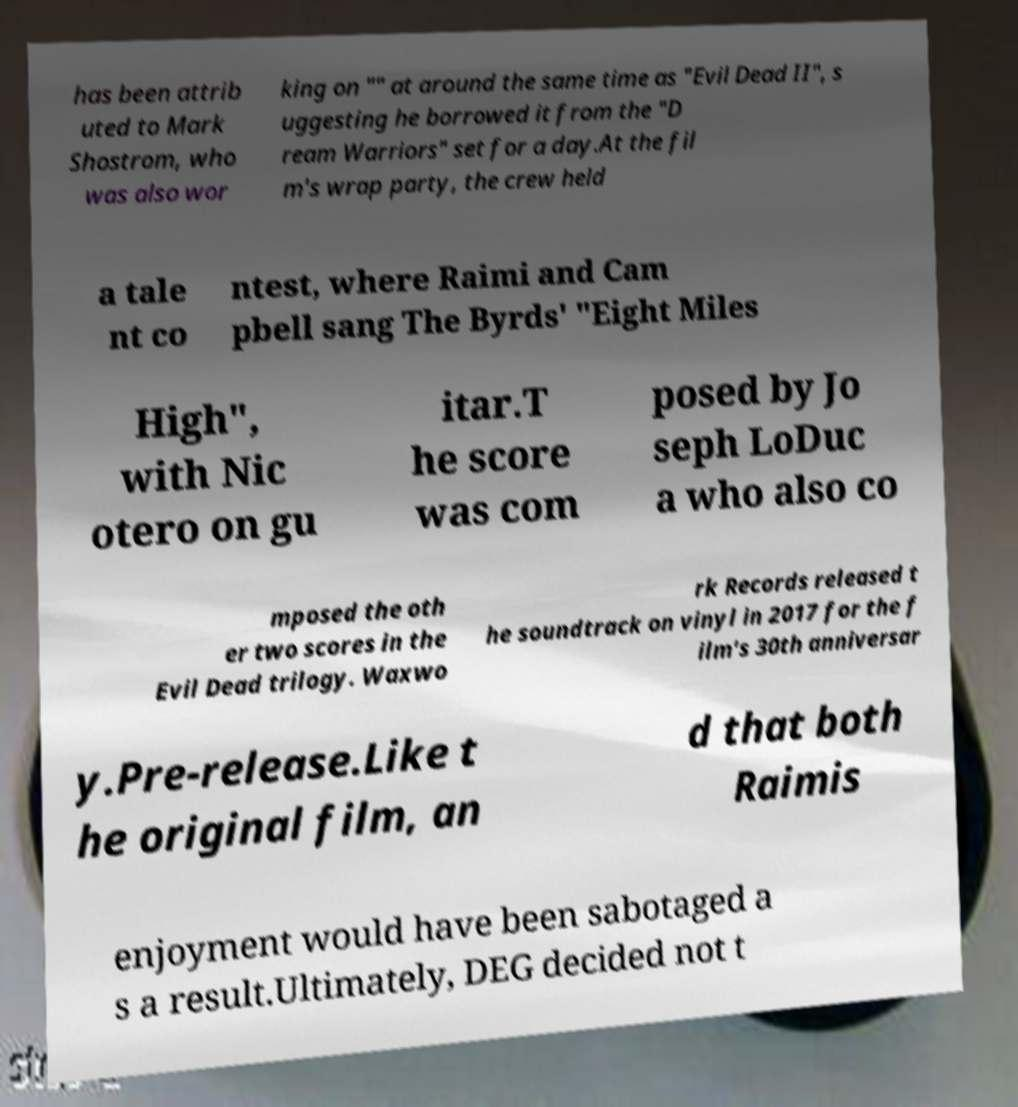I need the written content from this picture converted into text. Can you do that? has been attrib uted to Mark Shostrom, who was also wor king on "" at around the same time as "Evil Dead II", s uggesting he borrowed it from the "D ream Warriors" set for a day.At the fil m's wrap party, the crew held a tale nt co ntest, where Raimi and Cam pbell sang The Byrds' "Eight Miles High", with Nic otero on gu itar.T he score was com posed by Jo seph LoDuc a who also co mposed the oth er two scores in the Evil Dead trilogy. Waxwo rk Records released t he soundtrack on vinyl in 2017 for the f ilm's 30th anniversar y.Pre-release.Like t he original film, an d that both Raimis enjoyment would have been sabotaged a s a result.Ultimately, DEG decided not t 